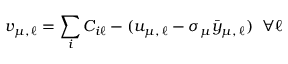Convert formula to latex. <formula><loc_0><loc_0><loc_500><loc_500>v _ { \mu , \, \ell } = \sum _ { i } C _ { i \ell } - ( u _ { \mu , \, \ell } - \sigma _ { \mu } \bar { y } _ { \mu , \, \ell } ) \, \forall \ell</formula> 